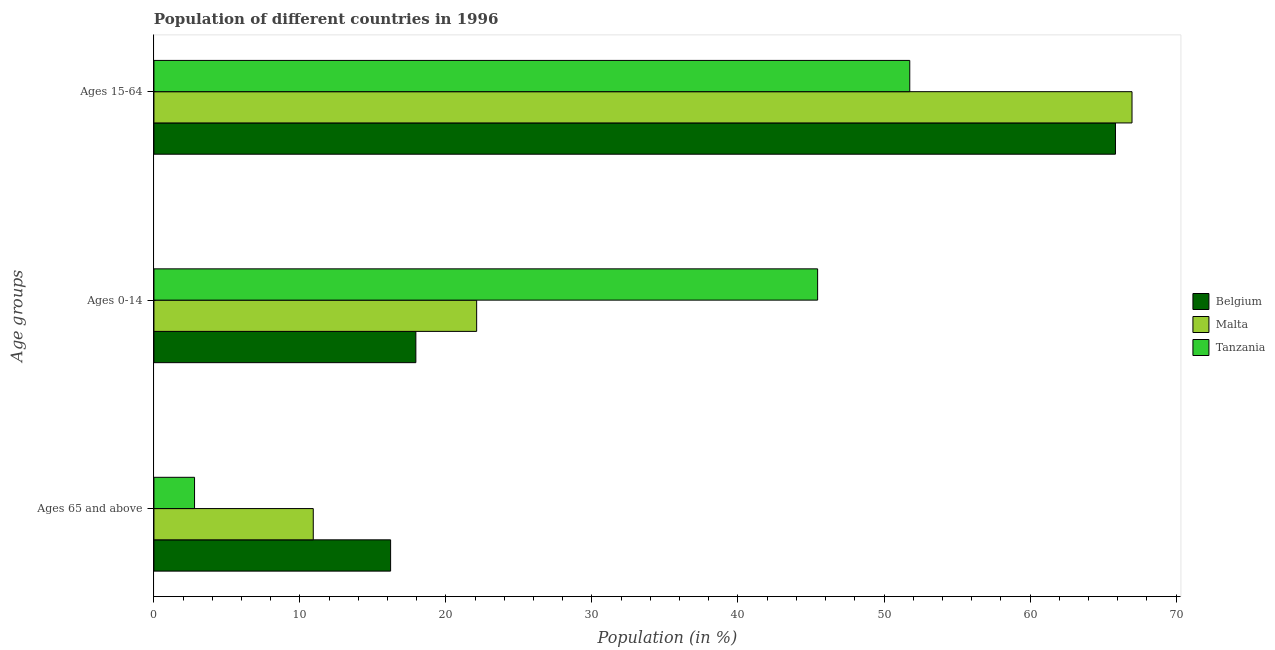How many different coloured bars are there?
Offer a very short reply. 3. How many groups of bars are there?
Provide a short and direct response. 3. How many bars are there on the 1st tick from the top?
Your answer should be compact. 3. What is the label of the 2nd group of bars from the top?
Offer a very short reply. Ages 0-14. What is the percentage of population within the age-group of 65 and above in Belgium?
Your response must be concise. 16.21. Across all countries, what is the maximum percentage of population within the age-group 0-14?
Offer a very short reply. 45.45. Across all countries, what is the minimum percentage of population within the age-group of 65 and above?
Offer a very short reply. 2.78. In which country was the percentage of population within the age-group 0-14 maximum?
Make the answer very short. Tanzania. In which country was the percentage of population within the age-group 0-14 minimum?
Your response must be concise. Belgium. What is the total percentage of population within the age-group 0-14 in the graph?
Your response must be concise. 85.49. What is the difference between the percentage of population within the age-group 0-14 in Malta and that in Tanzania?
Provide a succinct answer. -23.35. What is the difference between the percentage of population within the age-group of 65 and above in Tanzania and the percentage of population within the age-group 0-14 in Malta?
Give a very brief answer. -19.32. What is the average percentage of population within the age-group 15-64 per country?
Your answer should be very brief. 61.53. What is the difference between the percentage of population within the age-group 15-64 and percentage of population within the age-group of 65 and above in Belgium?
Your answer should be compact. 49.64. What is the ratio of the percentage of population within the age-group of 65 and above in Tanzania to that in Belgium?
Ensure brevity in your answer.  0.17. Is the percentage of population within the age-group 0-14 in Tanzania less than that in Malta?
Offer a very short reply. No. Is the difference between the percentage of population within the age-group of 65 and above in Malta and Belgium greater than the difference between the percentage of population within the age-group 0-14 in Malta and Belgium?
Ensure brevity in your answer.  No. What is the difference between the highest and the second highest percentage of population within the age-group 15-64?
Ensure brevity in your answer.  1.13. What is the difference between the highest and the lowest percentage of population within the age-group of 65 and above?
Your answer should be compact. 13.43. What does the 1st bar from the top in Ages 65 and above represents?
Make the answer very short. Tanzania. What does the 3rd bar from the bottom in Ages 15-64 represents?
Make the answer very short. Tanzania. Are all the bars in the graph horizontal?
Provide a succinct answer. Yes. What is the difference between two consecutive major ticks on the X-axis?
Your answer should be compact. 10. Are the values on the major ticks of X-axis written in scientific E-notation?
Provide a succinct answer. No. Does the graph contain any zero values?
Provide a succinct answer. No. Where does the legend appear in the graph?
Ensure brevity in your answer.  Center right. How many legend labels are there?
Your response must be concise. 3. What is the title of the graph?
Give a very brief answer. Population of different countries in 1996. What is the label or title of the X-axis?
Provide a succinct answer. Population (in %). What is the label or title of the Y-axis?
Give a very brief answer. Age groups. What is the Population (in %) in Belgium in Ages 65 and above?
Make the answer very short. 16.21. What is the Population (in %) in Malta in Ages 65 and above?
Your response must be concise. 10.91. What is the Population (in %) of Tanzania in Ages 65 and above?
Keep it short and to the point. 2.78. What is the Population (in %) in Belgium in Ages 0-14?
Your answer should be compact. 17.94. What is the Population (in %) of Malta in Ages 0-14?
Ensure brevity in your answer.  22.1. What is the Population (in %) of Tanzania in Ages 0-14?
Your answer should be compact. 45.45. What is the Population (in %) in Belgium in Ages 15-64?
Your answer should be compact. 65.85. What is the Population (in %) in Malta in Ages 15-64?
Provide a succinct answer. 66.98. What is the Population (in %) in Tanzania in Ages 15-64?
Your response must be concise. 51.76. Across all Age groups, what is the maximum Population (in %) in Belgium?
Offer a very short reply. 65.85. Across all Age groups, what is the maximum Population (in %) of Malta?
Your answer should be very brief. 66.98. Across all Age groups, what is the maximum Population (in %) in Tanzania?
Keep it short and to the point. 51.76. Across all Age groups, what is the minimum Population (in %) of Belgium?
Keep it short and to the point. 16.21. Across all Age groups, what is the minimum Population (in %) of Malta?
Your answer should be compact. 10.91. Across all Age groups, what is the minimum Population (in %) of Tanzania?
Provide a succinct answer. 2.78. What is the total Population (in %) in Belgium in the graph?
Provide a short and direct response. 100. What is the total Population (in %) of Malta in the graph?
Offer a very short reply. 100. What is the difference between the Population (in %) of Belgium in Ages 65 and above and that in Ages 0-14?
Offer a very short reply. -1.73. What is the difference between the Population (in %) in Malta in Ages 65 and above and that in Ages 0-14?
Ensure brevity in your answer.  -11.19. What is the difference between the Population (in %) in Tanzania in Ages 65 and above and that in Ages 0-14?
Ensure brevity in your answer.  -42.67. What is the difference between the Population (in %) in Belgium in Ages 65 and above and that in Ages 15-64?
Keep it short and to the point. -49.64. What is the difference between the Population (in %) in Malta in Ages 65 and above and that in Ages 15-64?
Offer a very short reply. -56.07. What is the difference between the Population (in %) in Tanzania in Ages 65 and above and that in Ages 15-64?
Ensure brevity in your answer.  -48.98. What is the difference between the Population (in %) in Belgium in Ages 0-14 and that in Ages 15-64?
Your response must be concise. -47.91. What is the difference between the Population (in %) in Malta in Ages 0-14 and that in Ages 15-64?
Provide a succinct answer. -44.88. What is the difference between the Population (in %) of Tanzania in Ages 0-14 and that in Ages 15-64?
Ensure brevity in your answer.  -6.31. What is the difference between the Population (in %) of Belgium in Ages 65 and above and the Population (in %) of Malta in Ages 0-14?
Give a very brief answer. -5.89. What is the difference between the Population (in %) of Belgium in Ages 65 and above and the Population (in %) of Tanzania in Ages 0-14?
Your answer should be compact. -29.25. What is the difference between the Population (in %) of Malta in Ages 65 and above and the Population (in %) of Tanzania in Ages 0-14?
Provide a short and direct response. -34.54. What is the difference between the Population (in %) of Belgium in Ages 65 and above and the Population (in %) of Malta in Ages 15-64?
Keep it short and to the point. -50.78. What is the difference between the Population (in %) in Belgium in Ages 65 and above and the Population (in %) in Tanzania in Ages 15-64?
Keep it short and to the point. -35.55. What is the difference between the Population (in %) of Malta in Ages 65 and above and the Population (in %) of Tanzania in Ages 15-64?
Your response must be concise. -40.85. What is the difference between the Population (in %) of Belgium in Ages 0-14 and the Population (in %) of Malta in Ages 15-64?
Your answer should be very brief. -49.05. What is the difference between the Population (in %) in Belgium in Ages 0-14 and the Population (in %) in Tanzania in Ages 15-64?
Ensure brevity in your answer.  -33.83. What is the difference between the Population (in %) of Malta in Ages 0-14 and the Population (in %) of Tanzania in Ages 15-64?
Make the answer very short. -29.66. What is the average Population (in %) of Belgium per Age groups?
Make the answer very short. 33.33. What is the average Population (in %) of Malta per Age groups?
Offer a very short reply. 33.33. What is the average Population (in %) of Tanzania per Age groups?
Provide a succinct answer. 33.33. What is the difference between the Population (in %) in Belgium and Population (in %) in Malta in Ages 65 and above?
Keep it short and to the point. 5.3. What is the difference between the Population (in %) in Belgium and Population (in %) in Tanzania in Ages 65 and above?
Give a very brief answer. 13.43. What is the difference between the Population (in %) of Malta and Population (in %) of Tanzania in Ages 65 and above?
Keep it short and to the point. 8.13. What is the difference between the Population (in %) in Belgium and Population (in %) in Malta in Ages 0-14?
Ensure brevity in your answer.  -4.16. What is the difference between the Population (in %) of Belgium and Population (in %) of Tanzania in Ages 0-14?
Your answer should be compact. -27.52. What is the difference between the Population (in %) of Malta and Population (in %) of Tanzania in Ages 0-14?
Make the answer very short. -23.35. What is the difference between the Population (in %) of Belgium and Population (in %) of Malta in Ages 15-64?
Ensure brevity in your answer.  -1.13. What is the difference between the Population (in %) in Belgium and Population (in %) in Tanzania in Ages 15-64?
Your answer should be compact. 14.09. What is the difference between the Population (in %) of Malta and Population (in %) of Tanzania in Ages 15-64?
Provide a succinct answer. 15.22. What is the ratio of the Population (in %) in Belgium in Ages 65 and above to that in Ages 0-14?
Offer a terse response. 0.9. What is the ratio of the Population (in %) in Malta in Ages 65 and above to that in Ages 0-14?
Make the answer very short. 0.49. What is the ratio of the Population (in %) of Tanzania in Ages 65 and above to that in Ages 0-14?
Your answer should be very brief. 0.06. What is the ratio of the Population (in %) in Belgium in Ages 65 and above to that in Ages 15-64?
Provide a short and direct response. 0.25. What is the ratio of the Population (in %) of Malta in Ages 65 and above to that in Ages 15-64?
Your answer should be compact. 0.16. What is the ratio of the Population (in %) of Tanzania in Ages 65 and above to that in Ages 15-64?
Offer a very short reply. 0.05. What is the ratio of the Population (in %) of Belgium in Ages 0-14 to that in Ages 15-64?
Your response must be concise. 0.27. What is the ratio of the Population (in %) in Malta in Ages 0-14 to that in Ages 15-64?
Ensure brevity in your answer.  0.33. What is the ratio of the Population (in %) in Tanzania in Ages 0-14 to that in Ages 15-64?
Make the answer very short. 0.88. What is the difference between the highest and the second highest Population (in %) of Belgium?
Give a very brief answer. 47.91. What is the difference between the highest and the second highest Population (in %) in Malta?
Your answer should be compact. 44.88. What is the difference between the highest and the second highest Population (in %) of Tanzania?
Make the answer very short. 6.31. What is the difference between the highest and the lowest Population (in %) in Belgium?
Offer a very short reply. 49.64. What is the difference between the highest and the lowest Population (in %) of Malta?
Your answer should be very brief. 56.07. What is the difference between the highest and the lowest Population (in %) of Tanzania?
Offer a terse response. 48.98. 